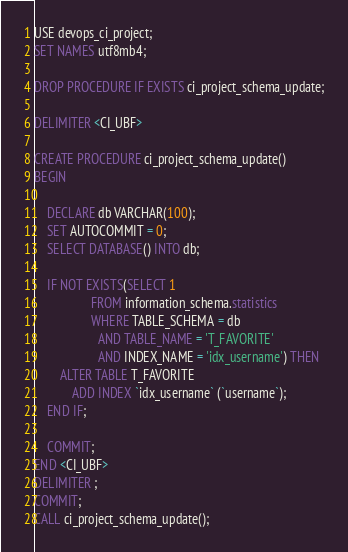Convert code to text. <code><loc_0><loc_0><loc_500><loc_500><_SQL_>USE devops_ci_project;
SET NAMES utf8mb4;

DROP PROCEDURE IF EXISTS ci_project_schema_update;

DELIMITER <CI_UBF>

CREATE PROCEDURE ci_project_schema_update()
BEGIN

    DECLARE db VARCHAR(100);
    SET AUTOCOMMIT = 0;
    SELECT DATABASE() INTO db;

    IF NOT EXISTS(SELECT 1
                  FROM information_schema.statistics
                  WHERE TABLE_SCHEMA = db
                    AND TABLE_NAME = 'T_FAVORITE'
                    AND INDEX_NAME = 'idx_username') THEN
        ALTER TABLE T_FAVORITE
            ADD INDEX `idx_username` (`username`);
    END IF;

    COMMIT;
END <CI_UBF>
DELIMITER ;
COMMIT;
CALL ci_project_schema_update();
</code> 